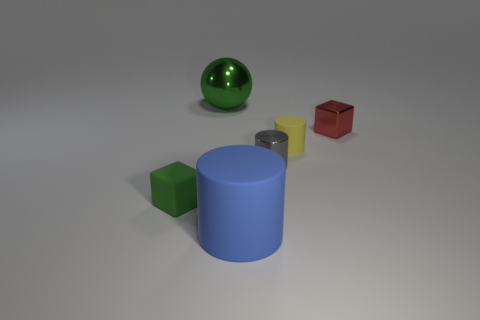Subtract all balls. How many objects are left? 5 Add 2 large blue metal objects. How many objects exist? 8 Add 4 small gray metallic cylinders. How many small gray metallic cylinders are left? 5 Add 4 blue matte things. How many blue matte things exist? 5 Subtract 0 brown cylinders. How many objects are left? 6 Subtract all big green metallic objects. Subtract all gray metal spheres. How many objects are left? 5 